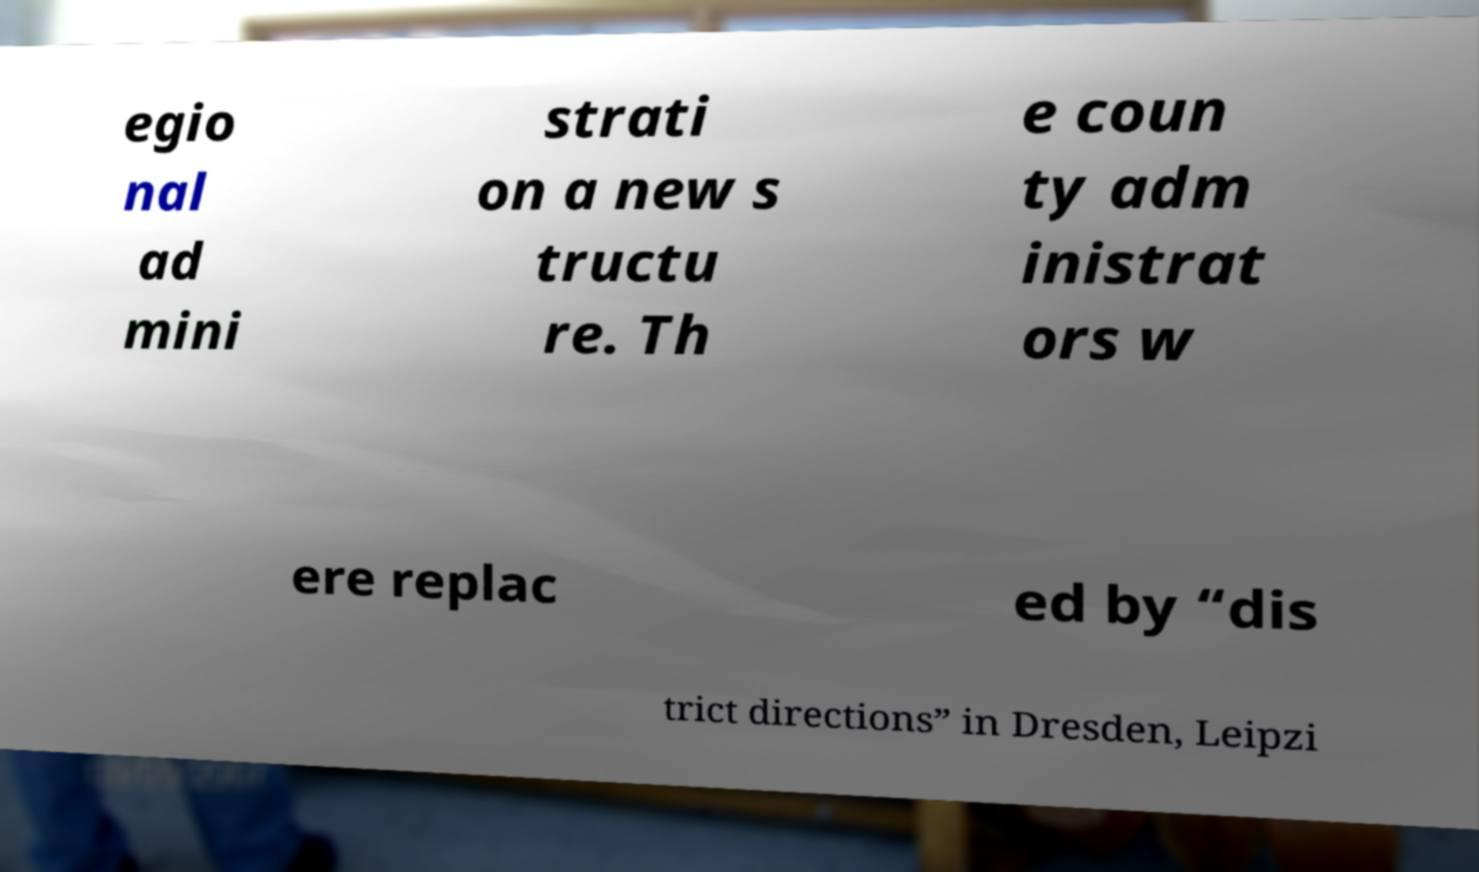For documentation purposes, I need the text within this image transcribed. Could you provide that? egio nal ad mini strati on a new s tructu re. Th e coun ty adm inistrat ors w ere replac ed by “dis trict directions” in Dresden, Leipzi 